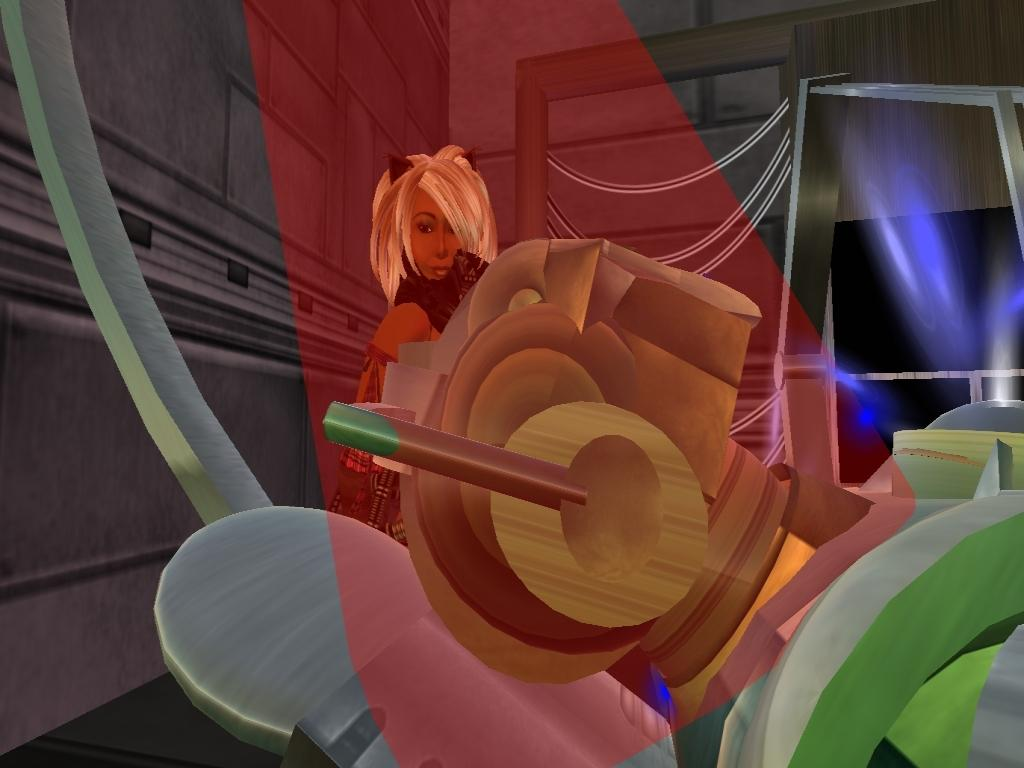What style is the image presented in? The image is a cartoon. What is the main subject of the image? There is a picture of a woman in the middle of the image. What type of chain is the woman holding in the image? There is no chain present in the image; it is a cartoon featuring a woman. 